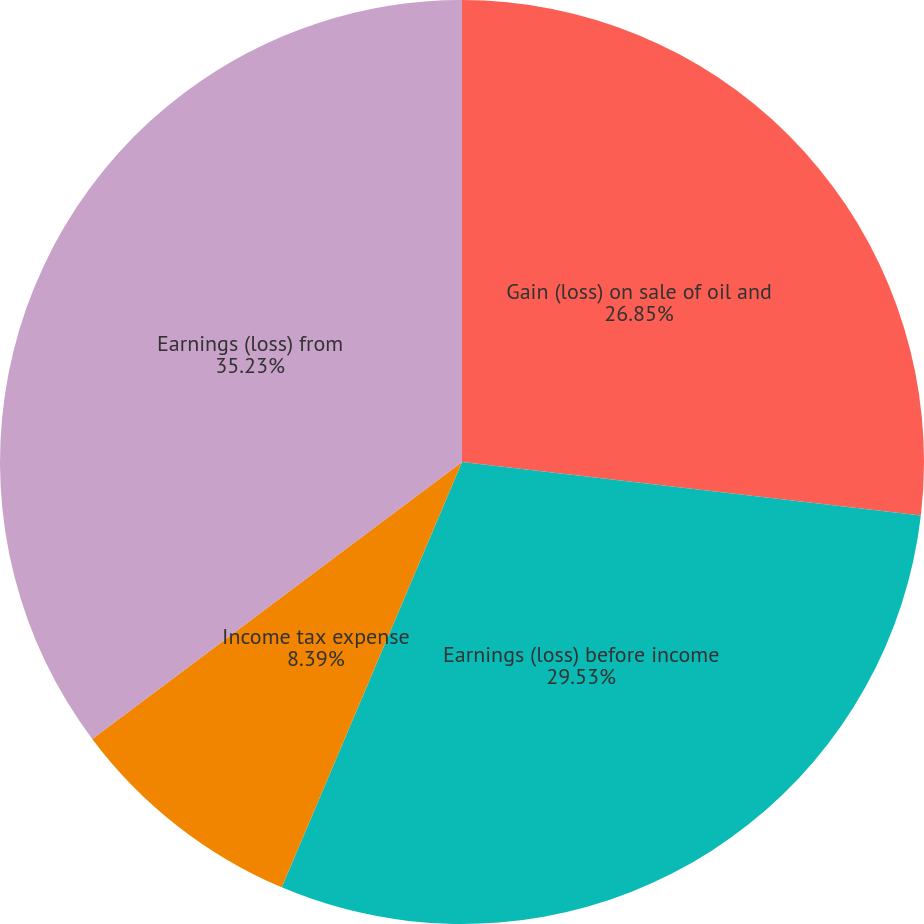<chart> <loc_0><loc_0><loc_500><loc_500><pie_chart><fcel>Gain (loss) on sale of oil and<fcel>Earnings (loss) before income<fcel>Income tax expense<fcel>Earnings (loss) from<nl><fcel>26.85%<fcel>29.53%<fcel>8.39%<fcel>35.23%<nl></chart> 